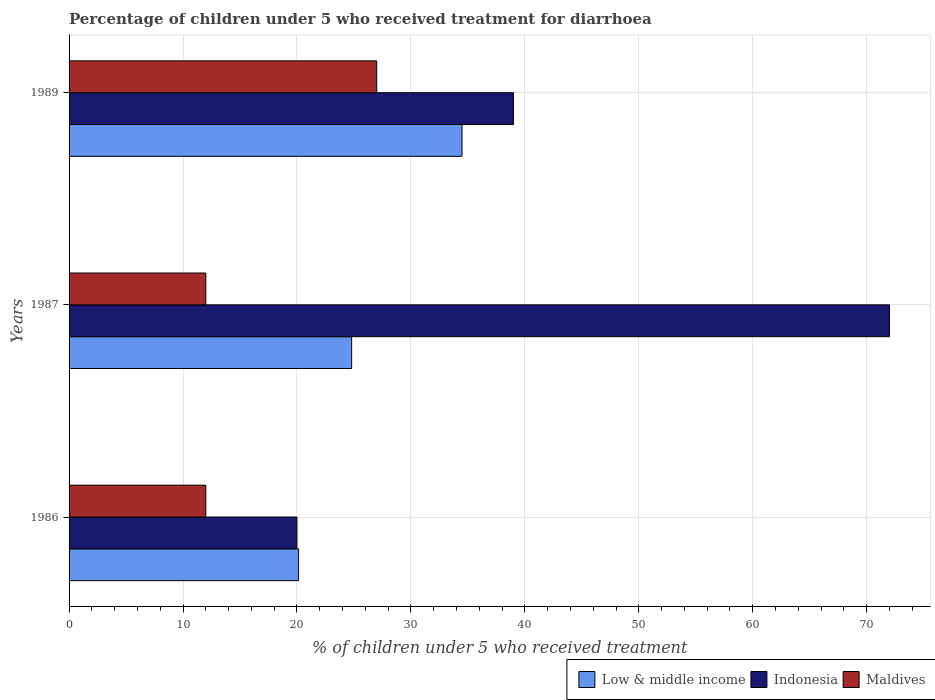How many different coloured bars are there?
Keep it short and to the point. 3. Are the number of bars per tick equal to the number of legend labels?
Offer a terse response. Yes. Are the number of bars on each tick of the Y-axis equal?
Offer a terse response. Yes. How many bars are there on the 3rd tick from the bottom?
Keep it short and to the point. 3. What is the percentage of children who received treatment for diarrhoea  in Low & middle income in 1986?
Offer a very short reply. 20.14. Across all years, what is the maximum percentage of children who received treatment for diarrhoea  in Low & middle income?
Offer a very short reply. 34.48. Across all years, what is the minimum percentage of children who received treatment for diarrhoea  in Low & middle income?
Your answer should be compact. 20.14. In which year was the percentage of children who received treatment for diarrhoea  in Indonesia maximum?
Your response must be concise. 1987. What is the total percentage of children who received treatment for diarrhoea  in Low & middle income in the graph?
Offer a terse response. 79.42. What is the difference between the percentage of children who received treatment for diarrhoea  in Low & middle income in 1987 and the percentage of children who received treatment for diarrhoea  in Maldives in 1986?
Make the answer very short. 12.8. What is the average percentage of children who received treatment for diarrhoea  in Low & middle income per year?
Make the answer very short. 26.47. What is the ratio of the percentage of children who received treatment for diarrhoea  in Maldives in 1986 to that in 1989?
Provide a succinct answer. 0.44. Is the percentage of children who received treatment for diarrhoea  in Indonesia in 1986 less than that in 1987?
Keep it short and to the point. Yes. Is the difference between the percentage of children who received treatment for diarrhoea  in Indonesia in 1986 and 1989 greater than the difference between the percentage of children who received treatment for diarrhoea  in Maldives in 1986 and 1989?
Provide a short and direct response. No. What is the difference between the highest and the second highest percentage of children who received treatment for diarrhoea  in Maldives?
Give a very brief answer. 15. What is the difference between the highest and the lowest percentage of children who received treatment for diarrhoea  in Indonesia?
Your response must be concise. 52. In how many years, is the percentage of children who received treatment for diarrhoea  in Indonesia greater than the average percentage of children who received treatment for diarrhoea  in Indonesia taken over all years?
Make the answer very short. 1. Is the sum of the percentage of children who received treatment for diarrhoea  in Indonesia in 1986 and 1987 greater than the maximum percentage of children who received treatment for diarrhoea  in Maldives across all years?
Your answer should be very brief. Yes. What does the 1st bar from the top in 1989 represents?
Your answer should be very brief. Maldives. What does the 1st bar from the bottom in 1987 represents?
Provide a short and direct response. Low & middle income. How many years are there in the graph?
Your answer should be very brief. 3. What is the difference between two consecutive major ticks on the X-axis?
Your answer should be very brief. 10. Are the values on the major ticks of X-axis written in scientific E-notation?
Provide a succinct answer. No. How many legend labels are there?
Offer a terse response. 3. What is the title of the graph?
Provide a succinct answer. Percentage of children under 5 who received treatment for diarrhoea. Does "Eritrea" appear as one of the legend labels in the graph?
Give a very brief answer. No. What is the label or title of the X-axis?
Provide a short and direct response. % of children under 5 who received treatment. What is the % of children under 5 who received treatment in Low & middle income in 1986?
Offer a terse response. 20.14. What is the % of children under 5 who received treatment of Indonesia in 1986?
Ensure brevity in your answer.  20. What is the % of children under 5 who received treatment of Maldives in 1986?
Keep it short and to the point. 12. What is the % of children under 5 who received treatment of Low & middle income in 1987?
Your answer should be very brief. 24.8. What is the % of children under 5 who received treatment in Indonesia in 1987?
Keep it short and to the point. 72. What is the % of children under 5 who received treatment in Low & middle income in 1989?
Offer a very short reply. 34.48. What is the % of children under 5 who received treatment of Indonesia in 1989?
Keep it short and to the point. 39. What is the % of children under 5 who received treatment in Maldives in 1989?
Offer a terse response. 27. Across all years, what is the maximum % of children under 5 who received treatment in Low & middle income?
Offer a very short reply. 34.48. Across all years, what is the maximum % of children under 5 who received treatment of Maldives?
Offer a very short reply. 27. Across all years, what is the minimum % of children under 5 who received treatment of Low & middle income?
Offer a very short reply. 20.14. Across all years, what is the minimum % of children under 5 who received treatment in Indonesia?
Ensure brevity in your answer.  20. What is the total % of children under 5 who received treatment of Low & middle income in the graph?
Keep it short and to the point. 79.42. What is the total % of children under 5 who received treatment in Indonesia in the graph?
Your answer should be compact. 131. What is the total % of children under 5 who received treatment of Maldives in the graph?
Ensure brevity in your answer.  51. What is the difference between the % of children under 5 who received treatment of Low & middle income in 1986 and that in 1987?
Your answer should be compact. -4.66. What is the difference between the % of children under 5 who received treatment in Indonesia in 1986 and that in 1987?
Your answer should be compact. -52. What is the difference between the % of children under 5 who received treatment of Low & middle income in 1986 and that in 1989?
Offer a very short reply. -14.34. What is the difference between the % of children under 5 who received treatment in Indonesia in 1986 and that in 1989?
Provide a succinct answer. -19. What is the difference between the % of children under 5 who received treatment in Maldives in 1986 and that in 1989?
Offer a very short reply. -15. What is the difference between the % of children under 5 who received treatment in Low & middle income in 1987 and that in 1989?
Give a very brief answer. -9.68. What is the difference between the % of children under 5 who received treatment in Low & middle income in 1986 and the % of children under 5 who received treatment in Indonesia in 1987?
Provide a short and direct response. -51.86. What is the difference between the % of children under 5 who received treatment in Low & middle income in 1986 and the % of children under 5 who received treatment in Maldives in 1987?
Keep it short and to the point. 8.14. What is the difference between the % of children under 5 who received treatment in Indonesia in 1986 and the % of children under 5 who received treatment in Maldives in 1987?
Give a very brief answer. 8. What is the difference between the % of children under 5 who received treatment in Low & middle income in 1986 and the % of children under 5 who received treatment in Indonesia in 1989?
Your answer should be very brief. -18.86. What is the difference between the % of children under 5 who received treatment of Low & middle income in 1986 and the % of children under 5 who received treatment of Maldives in 1989?
Your answer should be very brief. -6.86. What is the difference between the % of children under 5 who received treatment of Indonesia in 1986 and the % of children under 5 who received treatment of Maldives in 1989?
Offer a very short reply. -7. What is the difference between the % of children under 5 who received treatment of Low & middle income in 1987 and the % of children under 5 who received treatment of Indonesia in 1989?
Keep it short and to the point. -14.2. What is the difference between the % of children under 5 who received treatment of Low & middle income in 1987 and the % of children under 5 who received treatment of Maldives in 1989?
Ensure brevity in your answer.  -2.2. What is the difference between the % of children under 5 who received treatment in Indonesia in 1987 and the % of children under 5 who received treatment in Maldives in 1989?
Provide a short and direct response. 45. What is the average % of children under 5 who received treatment in Low & middle income per year?
Your answer should be very brief. 26.47. What is the average % of children under 5 who received treatment in Indonesia per year?
Ensure brevity in your answer.  43.67. In the year 1986, what is the difference between the % of children under 5 who received treatment in Low & middle income and % of children under 5 who received treatment in Indonesia?
Your response must be concise. 0.14. In the year 1986, what is the difference between the % of children under 5 who received treatment of Low & middle income and % of children under 5 who received treatment of Maldives?
Your answer should be compact. 8.14. In the year 1987, what is the difference between the % of children under 5 who received treatment in Low & middle income and % of children under 5 who received treatment in Indonesia?
Your response must be concise. -47.2. In the year 1987, what is the difference between the % of children under 5 who received treatment in Low & middle income and % of children under 5 who received treatment in Maldives?
Provide a short and direct response. 12.8. In the year 1989, what is the difference between the % of children under 5 who received treatment of Low & middle income and % of children under 5 who received treatment of Indonesia?
Ensure brevity in your answer.  -4.52. In the year 1989, what is the difference between the % of children under 5 who received treatment of Low & middle income and % of children under 5 who received treatment of Maldives?
Your answer should be compact. 7.48. In the year 1989, what is the difference between the % of children under 5 who received treatment in Indonesia and % of children under 5 who received treatment in Maldives?
Your answer should be very brief. 12. What is the ratio of the % of children under 5 who received treatment in Low & middle income in 1986 to that in 1987?
Provide a succinct answer. 0.81. What is the ratio of the % of children under 5 who received treatment in Indonesia in 1986 to that in 1987?
Keep it short and to the point. 0.28. What is the ratio of the % of children under 5 who received treatment in Maldives in 1986 to that in 1987?
Provide a short and direct response. 1. What is the ratio of the % of children under 5 who received treatment of Low & middle income in 1986 to that in 1989?
Offer a terse response. 0.58. What is the ratio of the % of children under 5 who received treatment of Indonesia in 1986 to that in 1989?
Keep it short and to the point. 0.51. What is the ratio of the % of children under 5 who received treatment of Maldives in 1986 to that in 1989?
Give a very brief answer. 0.44. What is the ratio of the % of children under 5 who received treatment of Low & middle income in 1987 to that in 1989?
Offer a terse response. 0.72. What is the ratio of the % of children under 5 who received treatment of Indonesia in 1987 to that in 1989?
Give a very brief answer. 1.85. What is the ratio of the % of children under 5 who received treatment of Maldives in 1987 to that in 1989?
Offer a terse response. 0.44. What is the difference between the highest and the second highest % of children under 5 who received treatment of Low & middle income?
Ensure brevity in your answer.  9.68. What is the difference between the highest and the second highest % of children under 5 who received treatment in Indonesia?
Provide a short and direct response. 33. What is the difference between the highest and the lowest % of children under 5 who received treatment of Low & middle income?
Offer a terse response. 14.34. What is the difference between the highest and the lowest % of children under 5 who received treatment of Indonesia?
Your response must be concise. 52. 